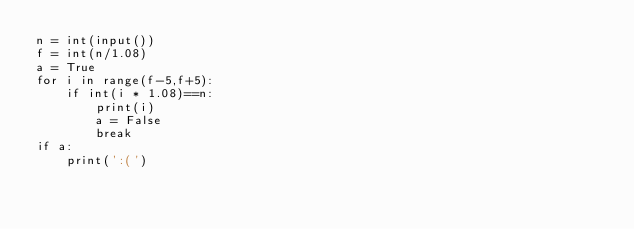Convert code to text. <code><loc_0><loc_0><loc_500><loc_500><_Python_>n = int(input())
f = int(n/1.08)
a = True
for i in range(f-5,f+5):
    if int(i * 1.08)==n:
        print(i)
        a = False
        break
if a:
    print(':(')</code> 